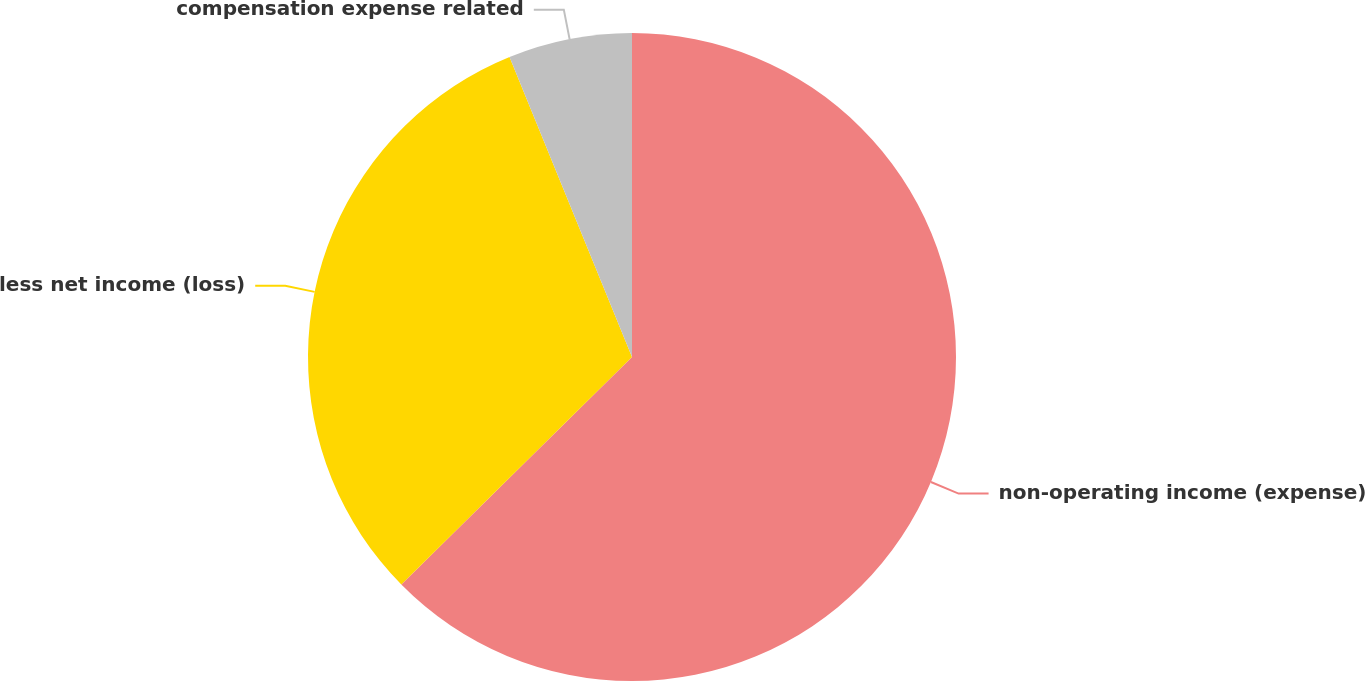Convert chart to OTSL. <chart><loc_0><loc_0><loc_500><loc_500><pie_chart><fcel>non-operating income (expense)<fcel>less net income (loss)<fcel>compensation expense related<nl><fcel>62.61%<fcel>31.22%<fcel>6.17%<nl></chart> 